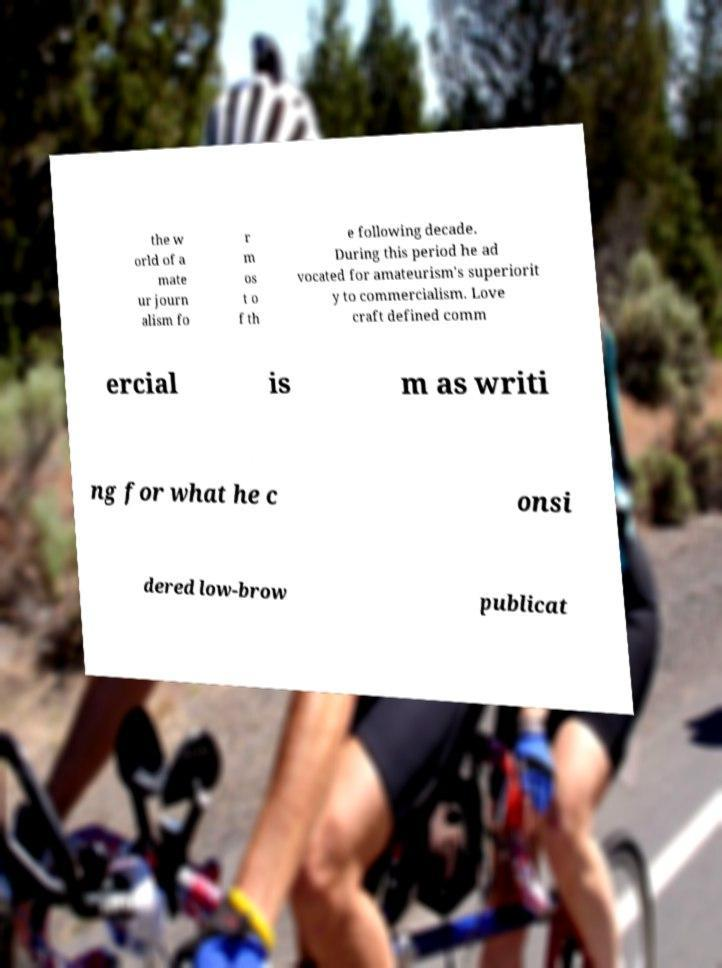Can you read and provide the text displayed in the image?This photo seems to have some interesting text. Can you extract and type it out for me? the w orld of a mate ur journ alism fo r m os t o f th e following decade. During this period he ad vocated for amateurism's superiorit y to commercialism. Love craft defined comm ercial is m as writi ng for what he c onsi dered low-brow publicat 